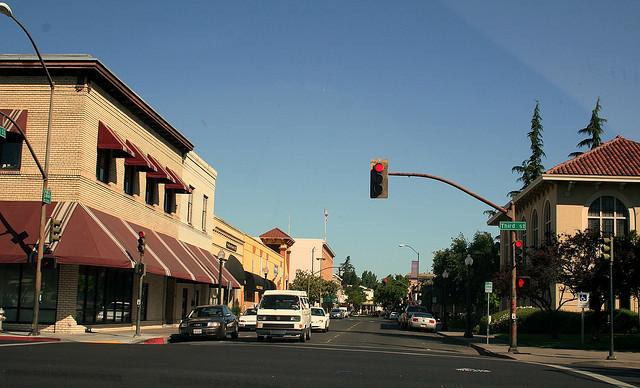From which material is the roofing most visible here sourced? Please explain your reasoning. clay. The type of roofing on the left building is may with clay. 